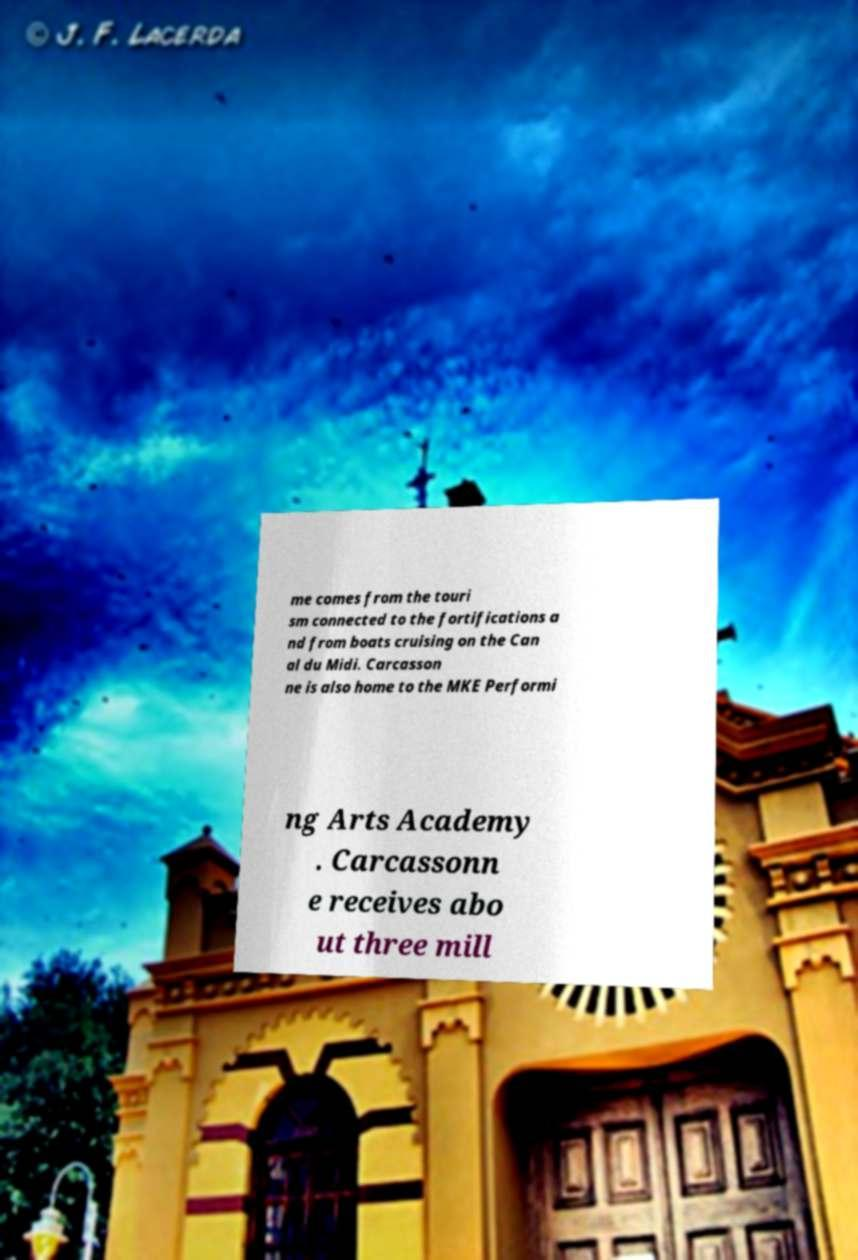I need the written content from this picture converted into text. Can you do that? me comes from the touri sm connected to the fortifications a nd from boats cruising on the Can al du Midi. Carcasson ne is also home to the MKE Performi ng Arts Academy . Carcassonn e receives abo ut three mill 